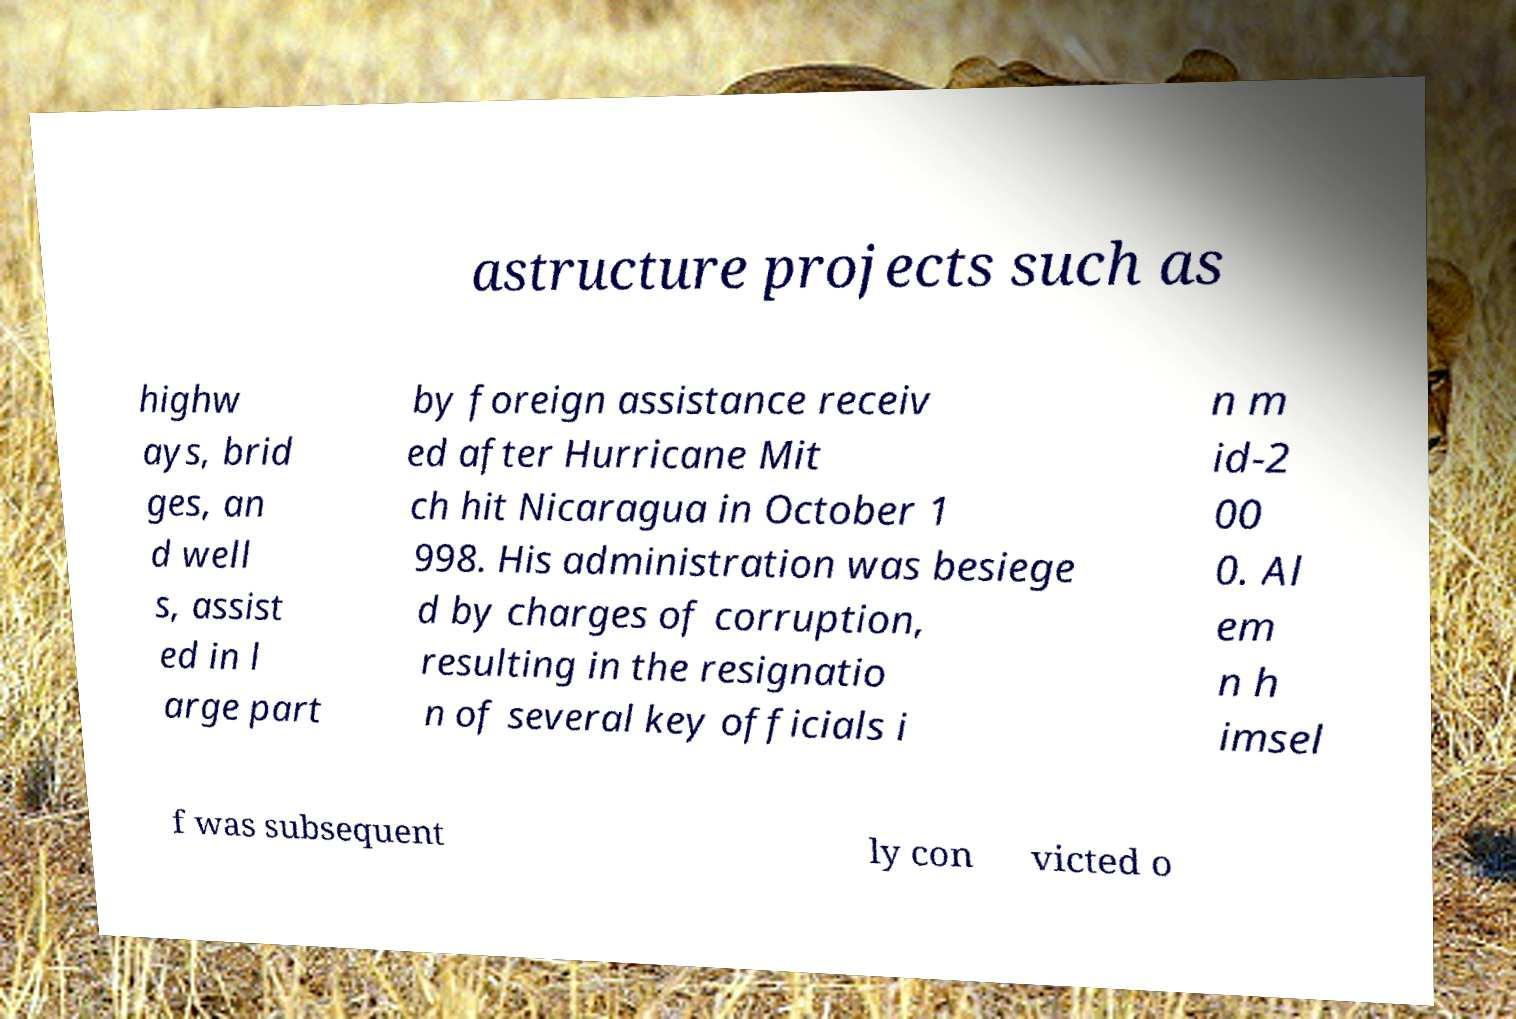Please read and relay the text visible in this image. What does it say? astructure projects such as highw ays, brid ges, an d well s, assist ed in l arge part by foreign assistance receiv ed after Hurricane Mit ch hit Nicaragua in October 1 998. His administration was besiege d by charges of corruption, resulting in the resignatio n of several key officials i n m id-2 00 0. Al em n h imsel f was subsequent ly con victed o 